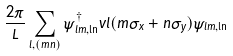<formula> <loc_0><loc_0><loc_500><loc_500>\frac { 2 \pi } { L } \sum _ { l , ( m n ) } \hat { \psi } ^ { \dagger } _ { l m , \ln } v l ( m \hat { \sigma } _ { x } + n \hat { \sigma } _ { y } ) \hat { \psi } _ { l m , \ln }</formula> 